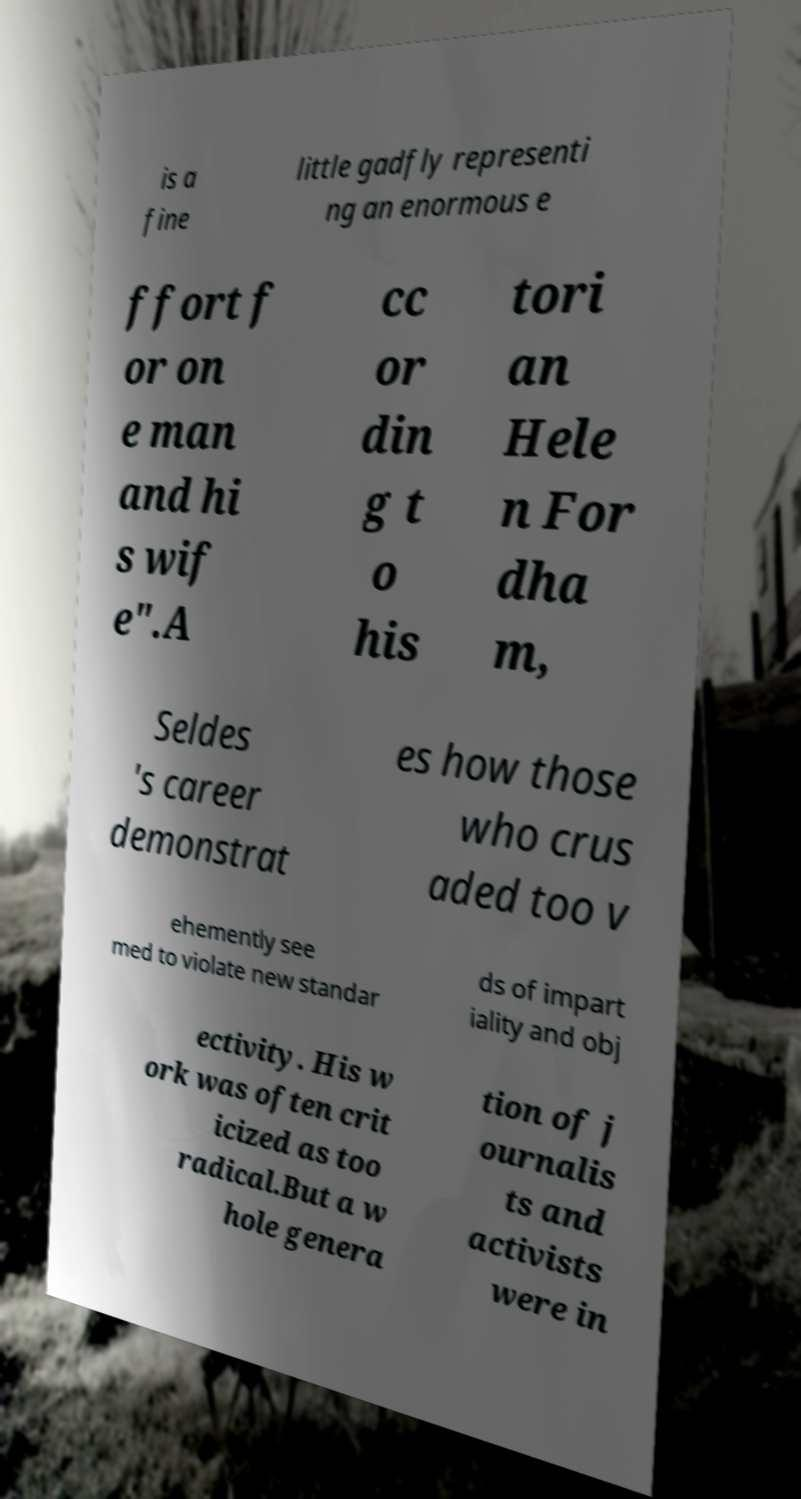There's text embedded in this image that I need extracted. Can you transcribe it verbatim? is a fine little gadfly representi ng an enormous e ffort f or on e man and hi s wif e".A cc or din g t o his tori an Hele n For dha m, Seldes 's career demonstrat es how those who crus aded too v ehemently see med to violate new standar ds of impart iality and obj ectivity. His w ork was often crit icized as too radical.But a w hole genera tion of j ournalis ts and activists were in 